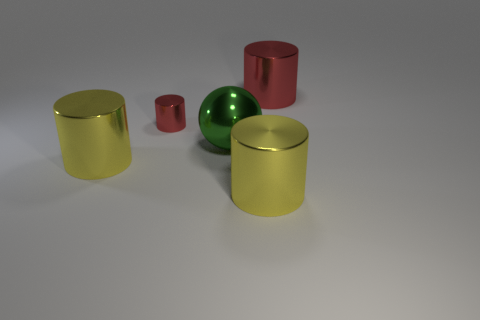There is a yellow cylinder left of the ball; is its size the same as the tiny red cylinder?
Keep it short and to the point. No. What color is the big metal cylinder that is on the left side of the big ball?
Your answer should be very brief. Yellow. What number of objects are there?
Provide a short and direct response. 5. What is the shape of the other red object that is made of the same material as the small red thing?
Make the answer very short. Cylinder. There is a object behind the tiny red shiny cylinder; is its color the same as the tiny object that is left of the green thing?
Make the answer very short. Yes. Is the number of big yellow metal cylinders on the left side of the green sphere the same as the number of large green metal spheres?
Give a very brief answer. Yes. How many large red cylinders are in front of the shiny ball?
Your answer should be very brief. 0. What size is the ball?
Offer a terse response. Large. The small cylinder that is made of the same material as the big red thing is what color?
Give a very brief answer. Red. How many red things have the same size as the green metallic ball?
Keep it short and to the point. 1. 